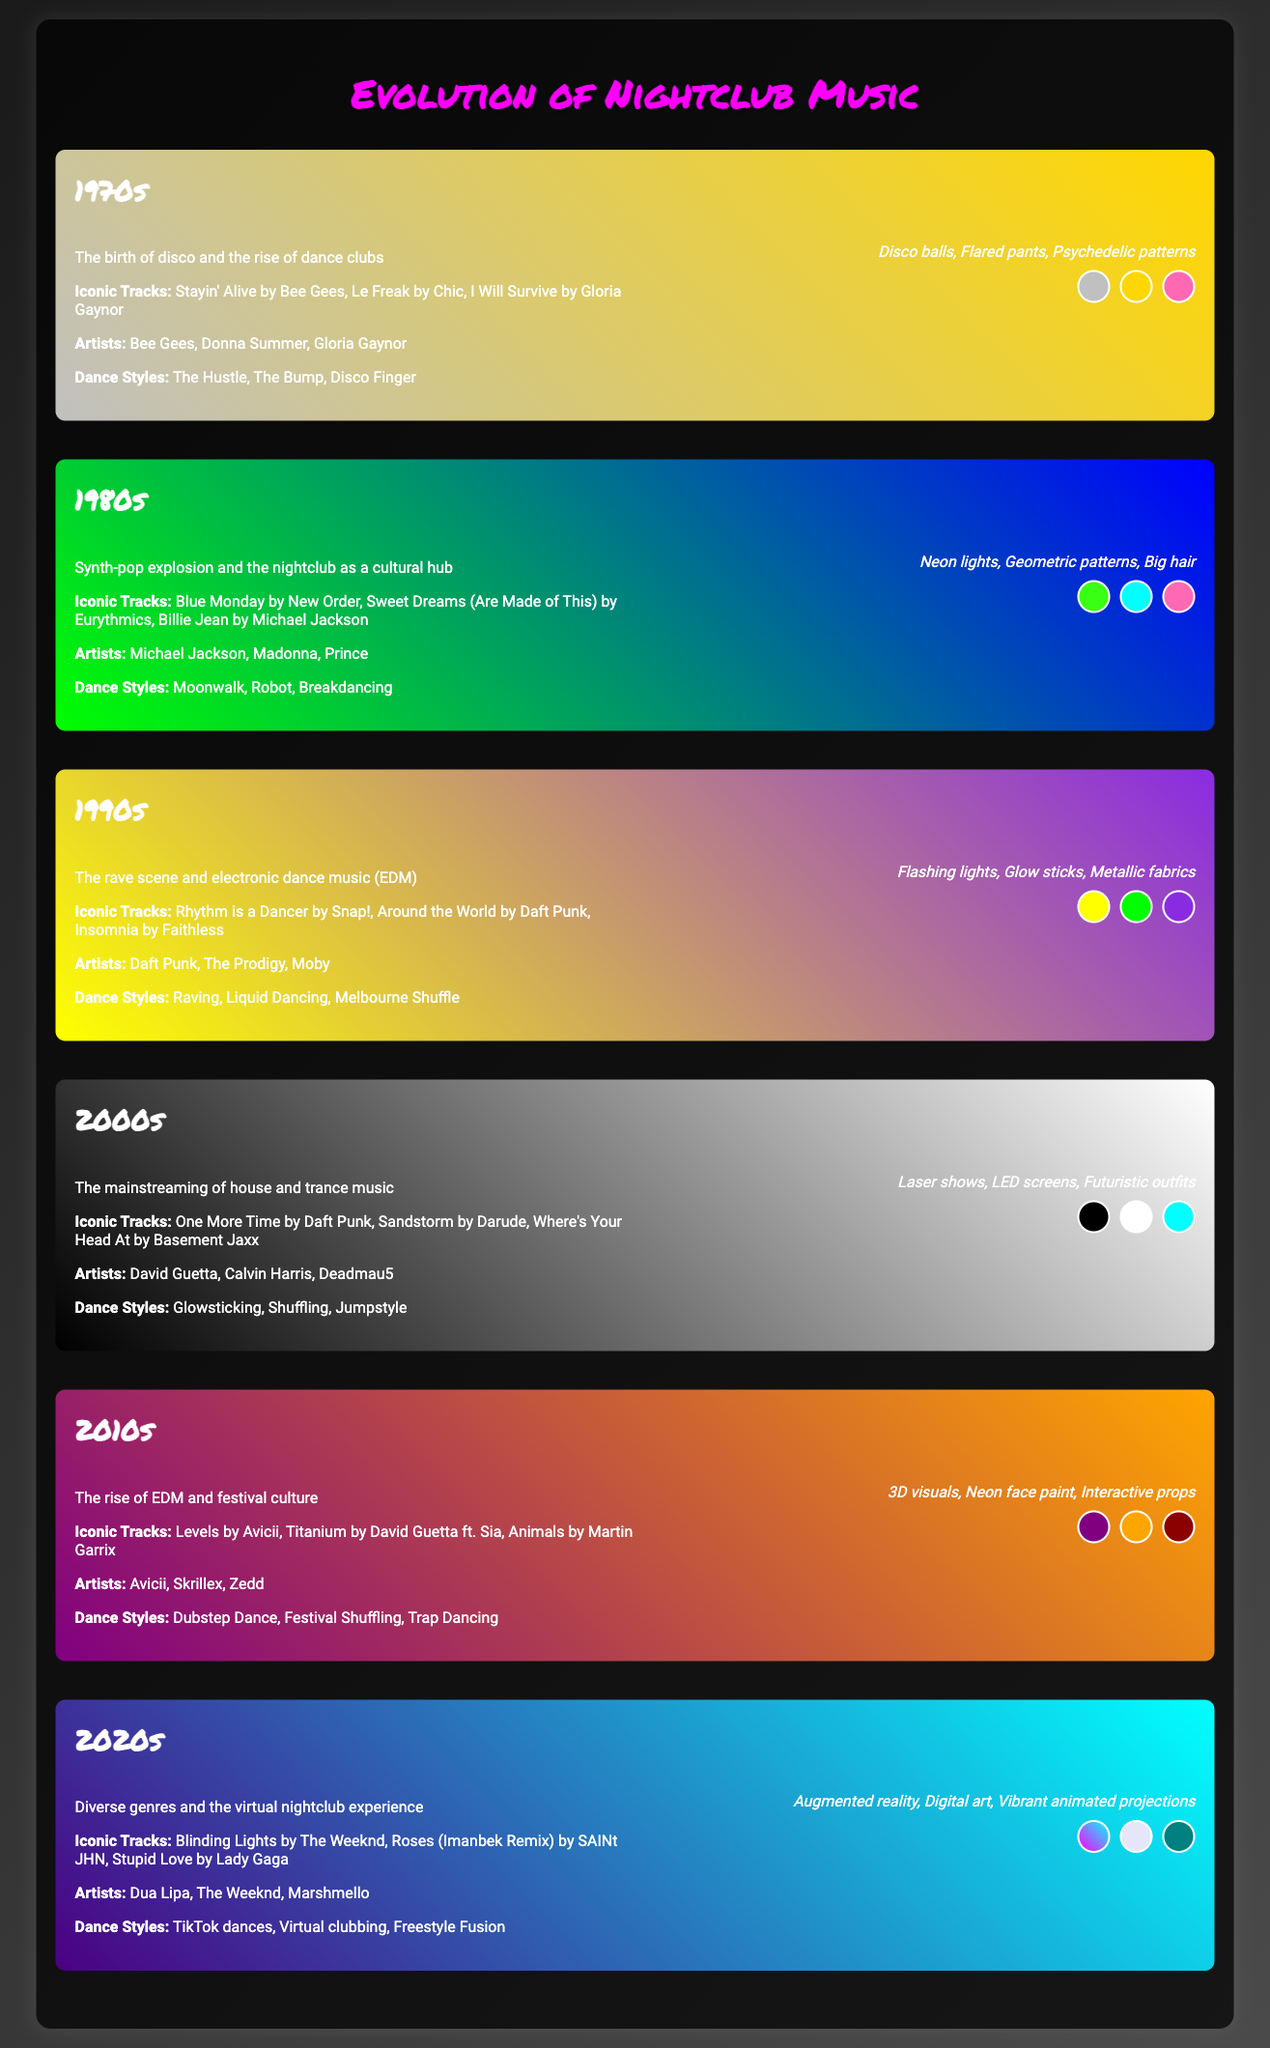What iconic track is associated with the 1970s? The question asks for one specific iconic track listed for the 1970s decade. The answer is "Stayin' Alive by Bee Gees."
Answer: Stayin' Alive by Bee Gees Which artist is linked to the 1980s decade? The question looks for an artist mentioned in the 1980s section of the document. The answer refers to "Michael Jackson."
Answer: Michael Jackson What dance style is identified with the 1990s? This question seeks a dance style highlighted in the 1990s decade. The answer is "Raving."
Answer: Raving How many decades are represented on the timeline? The question inquires about the total number of decades featured in the document. The answer is derived from counting the number of decade sections, which totals to "seven."
Answer: seven What visual element is mentioned for the 2000s? Here, the question seeks to identify a design element listed for the 2000s decade. The answer is "Laser shows."
Answer: Laser shows Which color swatch represents the 2010s? This question asks for a specific color used in the design for the 2010s decade. The answer refers specifically to one color, which is "#800080."
Answer: #800080 What genre dominated the 2020s in the document? The question seeks to uncover the primary genre mentioned for the 2020s decade. The answer is "Diverse genres."
Answer: Diverse genres What is the main feature of the nightclub scene in the 1980s? This question refers to a significant cultural aspect of the nightclub during the 1980s. The answer provided is "cultural hub."
Answer: cultural hub Which decade introduced electronic dance music (EDM)? The question seeks to identify the decade when EDM started to become notable. The answer is "1990s."
Answer: 1990s 